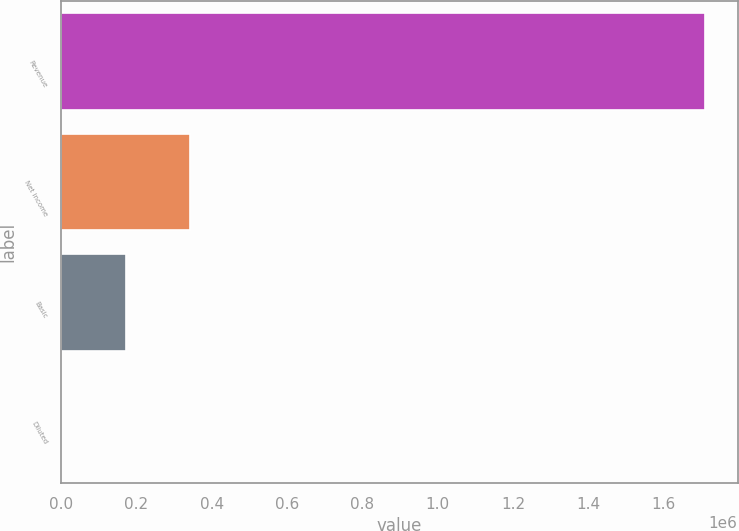<chart> <loc_0><loc_0><loc_500><loc_500><bar_chart><fcel>Revenue<fcel>Net income<fcel>Basic<fcel>Diluted<nl><fcel>1.7114e+06<fcel>342282<fcel>171141<fcel>0.71<nl></chart> 